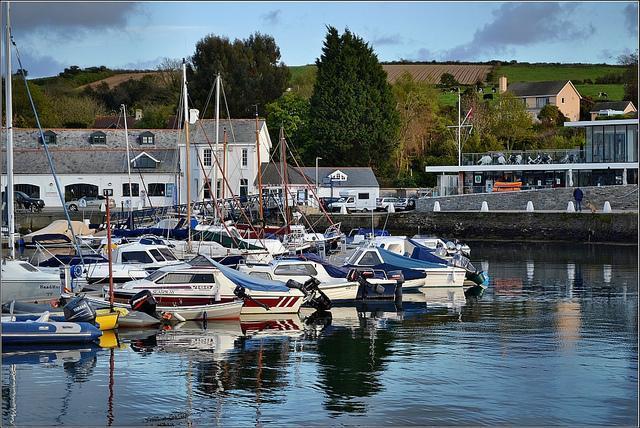How many boats are there?
Give a very brief answer. 8. How many horses in this photo?
Give a very brief answer. 0. 